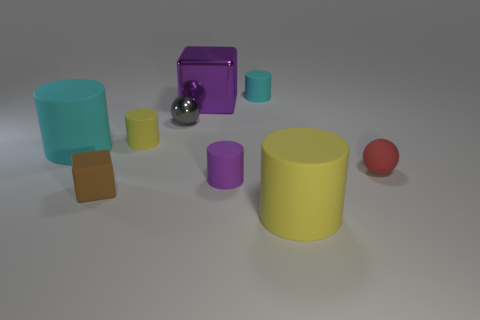Subtract all purple cylinders. How many cylinders are left? 4 Subtract 2 cylinders. How many cylinders are left? 3 Subtract all tiny purple rubber cylinders. How many cylinders are left? 4 Add 1 large rubber objects. How many objects exist? 10 Subtract all yellow cylinders. Subtract all green spheres. How many cylinders are left? 3 Subtract all cylinders. How many objects are left? 4 Subtract 1 red balls. How many objects are left? 8 Subtract all large cyan things. Subtract all big purple blocks. How many objects are left? 7 Add 1 tiny metallic things. How many tiny metallic things are left? 2 Add 5 large cyan metal blocks. How many large cyan metal blocks exist? 5 